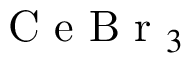Convert formula to latex. <formula><loc_0><loc_0><loc_500><loc_500>C e B r _ { 3 }</formula> 